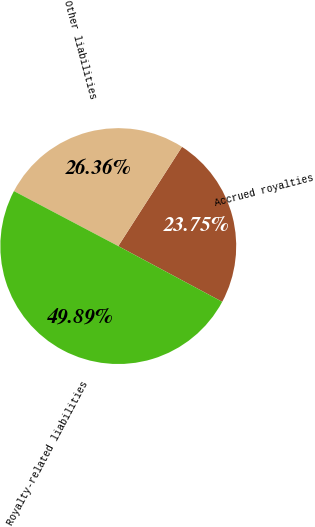Convert chart to OTSL. <chart><loc_0><loc_0><loc_500><loc_500><pie_chart><fcel>Accrued royalties<fcel>Other liabilities<fcel>Royalty-related liabilities<nl><fcel>23.75%<fcel>26.36%<fcel>49.89%<nl></chart> 